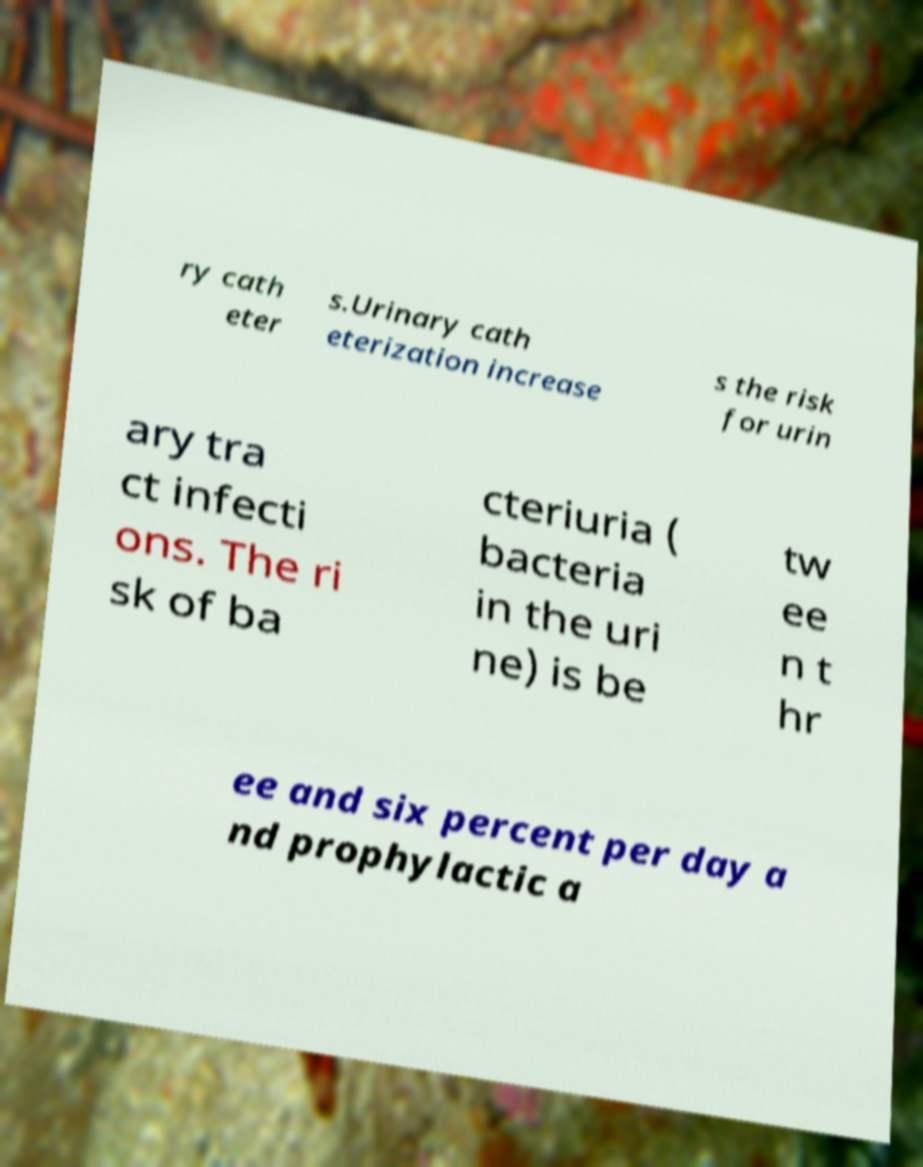For documentation purposes, I need the text within this image transcribed. Could you provide that? ry cath eter s.Urinary cath eterization increase s the risk for urin ary tra ct infecti ons. The ri sk of ba cteriuria ( bacteria in the uri ne) is be tw ee n t hr ee and six percent per day a nd prophylactic a 